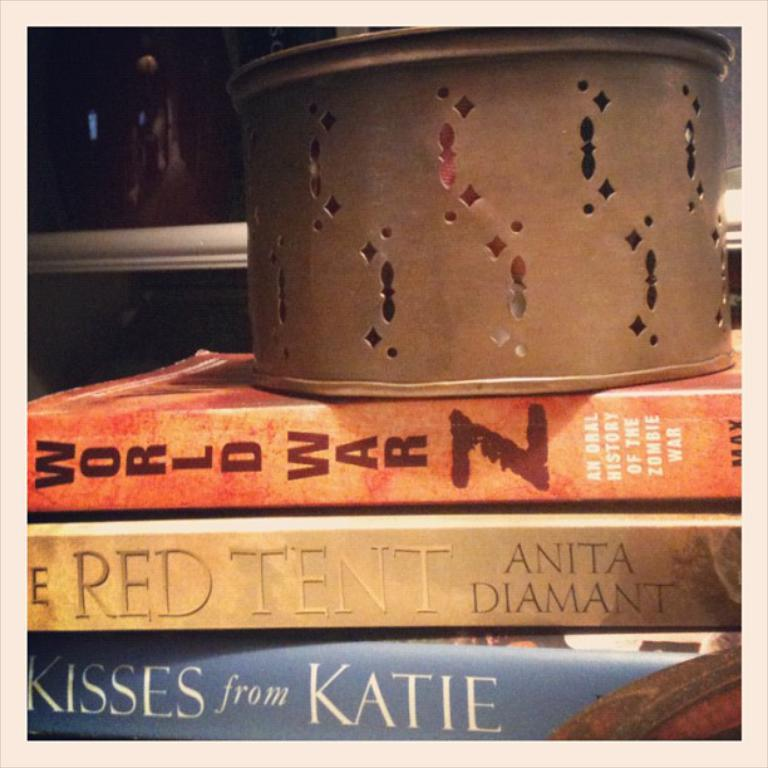Provide a one-sentence caption for the provided image. Several books and one that says Kisses from katie. 